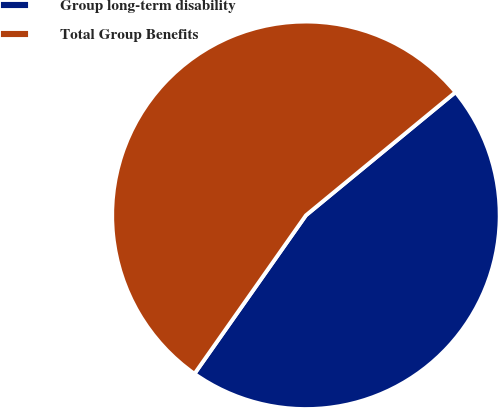Convert chart to OTSL. <chart><loc_0><loc_0><loc_500><loc_500><pie_chart><fcel>Group long-term disability<fcel>Total Group Benefits<nl><fcel>45.72%<fcel>54.28%<nl></chart> 